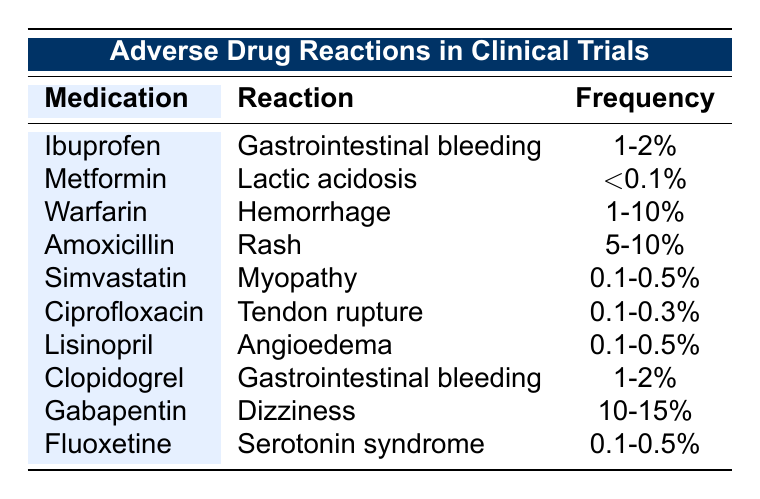What is the frequency of gastrointestinal bleeding associated with Ibuprofen? The table lists the frequency of gastrointestinal bleeding for Ibuprofen as 1-2%.
Answer: 1-2% Which medication has the highest reported frequency of adverse drug reactions? Gabapentin has the highest frequency reported, with 10-15% for dizziness.
Answer: 10-15% Is lactic acidosis a common adverse reaction of Metformin? The table indicates that lactic acidosis has a frequency of <0.1%, suggesting it is not common.
Answer: No What are the frequencies of rash related to Amoxicillin and myopathy related to Simvastatin? The frequency of rash for Amoxicillin is 5-10%, while for myopathy associated with Simvastatin it is 0.1-0.5%.
Answer: 5-10% and 0.1-0.5% Which two medications both have gastrointestinal bleeding as an adverse reaction? The medications Ibuprofen and Clopidogrel both list gastrointestinal bleeding as an adverse reaction, with frequencies of 1-2%.
Answer: Ibuprofen and Clopidogrel If you were to calculate the average frequency of myopathy for Simvastatin and dizziness for Gabapentin, what would that be? Myopathy for Simvastatin is 0.1-0.5%, which averages to 0.3%. Dizziness for Gabapentin is 10-15%, averaging to 12.5%. The overall average would be (0.3 + 12.5) / 2 = 6.4%.
Answer: 6.4% Is the frequency of tendon rupture for Ciprofloxacin greater than that for lactic acidosis in Metformin? Ciprofloxacin’s frequency is 0.1-0.3% for tendon rupture, while Metformin’s is <0.1% for lactic acidosis, indicating that tendon rupture occurs more frequently.
Answer: Yes What is the frequency range for hemorrhage associated with Warfarin? The table shows that the frequency of hemorrhage for Warfarin ranges from 1% to 10%.
Answer: 1-10% Which adverse reaction is associated with Clopidogrel, and what is its frequency? Clopidogrel is associated with gastrointestinal bleeding, which has a frequency of 1-2%.
Answer: Gastrointestinal bleeding, 1-2% If a drug has a frequency of 0.1% for an adverse reaction, is it associated with a high risk? A frequency of 0.1% is quite low, therefore it does not imply a high risk associated with the drug.
Answer: No 